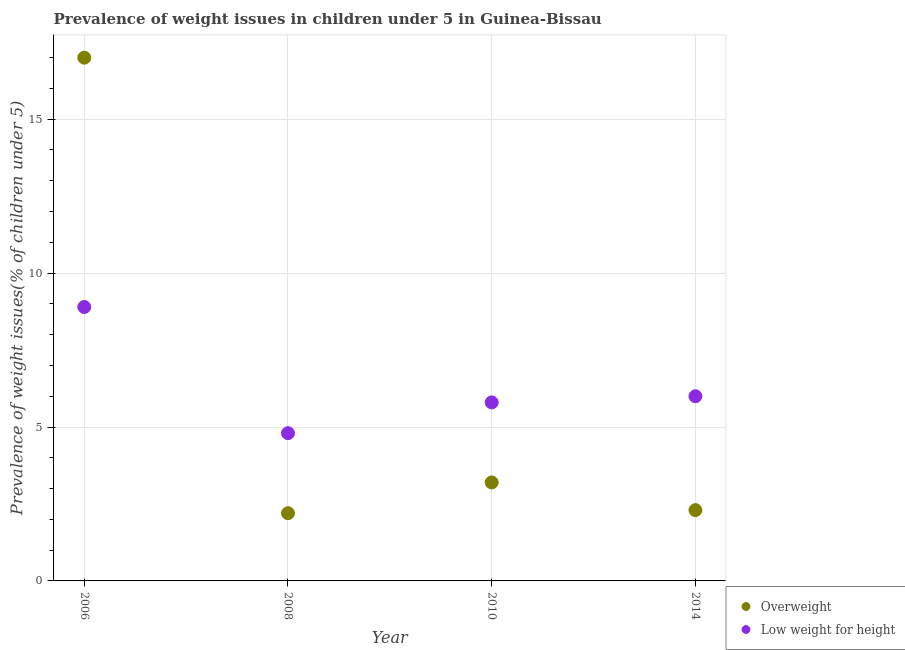How many different coloured dotlines are there?
Ensure brevity in your answer.  2. Is the number of dotlines equal to the number of legend labels?
Provide a short and direct response. Yes. What is the percentage of overweight children in 2008?
Provide a short and direct response. 2.2. Across all years, what is the minimum percentage of overweight children?
Keep it short and to the point. 2.2. What is the total percentage of overweight children in the graph?
Make the answer very short. 24.7. What is the difference between the percentage of underweight children in 2008 and that in 2014?
Keep it short and to the point. -1.2. What is the difference between the percentage of underweight children in 2010 and the percentage of overweight children in 2008?
Keep it short and to the point. 3.6. What is the average percentage of underweight children per year?
Your response must be concise. 6.37. In the year 2008, what is the difference between the percentage of overweight children and percentage of underweight children?
Keep it short and to the point. -2.6. What is the ratio of the percentage of underweight children in 2006 to that in 2010?
Offer a terse response. 1.53. Is the percentage of overweight children in 2008 less than that in 2014?
Your response must be concise. Yes. Is the difference between the percentage of underweight children in 2006 and 2010 greater than the difference between the percentage of overweight children in 2006 and 2010?
Offer a very short reply. No. What is the difference between the highest and the second highest percentage of overweight children?
Provide a short and direct response. 13.8. What is the difference between the highest and the lowest percentage of overweight children?
Provide a short and direct response. 14.8. Is the sum of the percentage of underweight children in 2006 and 2008 greater than the maximum percentage of overweight children across all years?
Make the answer very short. No. Is the percentage of underweight children strictly greater than the percentage of overweight children over the years?
Your response must be concise. No. How many years are there in the graph?
Your response must be concise. 4. What is the difference between two consecutive major ticks on the Y-axis?
Offer a very short reply. 5. Does the graph contain any zero values?
Your answer should be very brief. No. Where does the legend appear in the graph?
Provide a short and direct response. Bottom right. What is the title of the graph?
Your answer should be very brief. Prevalence of weight issues in children under 5 in Guinea-Bissau. Does "% of GNI" appear as one of the legend labels in the graph?
Your answer should be very brief. No. What is the label or title of the X-axis?
Your answer should be compact. Year. What is the label or title of the Y-axis?
Ensure brevity in your answer.  Prevalence of weight issues(% of children under 5). What is the Prevalence of weight issues(% of children under 5) in Low weight for height in 2006?
Provide a short and direct response. 8.9. What is the Prevalence of weight issues(% of children under 5) in Overweight in 2008?
Provide a succinct answer. 2.2. What is the Prevalence of weight issues(% of children under 5) of Low weight for height in 2008?
Provide a short and direct response. 4.8. What is the Prevalence of weight issues(% of children under 5) in Overweight in 2010?
Provide a short and direct response. 3.2. What is the Prevalence of weight issues(% of children under 5) in Low weight for height in 2010?
Provide a succinct answer. 5.8. What is the Prevalence of weight issues(% of children under 5) in Overweight in 2014?
Ensure brevity in your answer.  2.3. Across all years, what is the maximum Prevalence of weight issues(% of children under 5) in Overweight?
Provide a short and direct response. 17. Across all years, what is the maximum Prevalence of weight issues(% of children under 5) in Low weight for height?
Offer a terse response. 8.9. Across all years, what is the minimum Prevalence of weight issues(% of children under 5) of Overweight?
Provide a succinct answer. 2.2. Across all years, what is the minimum Prevalence of weight issues(% of children under 5) of Low weight for height?
Offer a very short reply. 4.8. What is the total Prevalence of weight issues(% of children under 5) of Overweight in the graph?
Give a very brief answer. 24.7. What is the total Prevalence of weight issues(% of children under 5) of Low weight for height in the graph?
Make the answer very short. 25.5. What is the difference between the Prevalence of weight issues(% of children under 5) of Overweight in 2006 and that in 2008?
Your response must be concise. 14.8. What is the difference between the Prevalence of weight issues(% of children under 5) of Low weight for height in 2006 and that in 2008?
Offer a very short reply. 4.1. What is the difference between the Prevalence of weight issues(% of children under 5) in Overweight in 2006 and that in 2014?
Your response must be concise. 14.7. What is the difference between the Prevalence of weight issues(% of children under 5) in Overweight in 2008 and that in 2010?
Provide a short and direct response. -1. What is the difference between the Prevalence of weight issues(% of children under 5) of Low weight for height in 2008 and that in 2010?
Provide a short and direct response. -1. What is the difference between the Prevalence of weight issues(% of children under 5) of Overweight in 2008 and that in 2014?
Give a very brief answer. -0.1. What is the difference between the Prevalence of weight issues(% of children under 5) of Low weight for height in 2008 and that in 2014?
Offer a very short reply. -1.2. What is the difference between the Prevalence of weight issues(% of children under 5) of Overweight in 2008 and the Prevalence of weight issues(% of children under 5) of Low weight for height in 2014?
Provide a short and direct response. -3.8. What is the difference between the Prevalence of weight issues(% of children under 5) of Overweight in 2010 and the Prevalence of weight issues(% of children under 5) of Low weight for height in 2014?
Provide a succinct answer. -2.8. What is the average Prevalence of weight issues(% of children under 5) in Overweight per year?
Give a very brief answer. 6.17. What is the average Prevalence of weight issues(% of children under 5) in Low weight for height per year?
Keep it short and to the point. 6.38. In the year 2006, what is the difference between the Prevalence of weight issues(% of children under 5) in Overweight and Prevalence of weight issues(% of children under 5) in Low weight for height?
Your answer should be very brief. 8.1. In the year 2014, what is the difference between the Prevalence of weight issues(% of children under 5) of Overweight and Prevalence of weight issues(% of children under 5) of Low weight for height?
Offer a terse response. -3.7. What is the ratio of the Prevalence of weight issues(% of children under 5) of Overweight in 2006 to that in 2008?
Your answer should be compact. 7.73. What is the ratio of the Prevalence of weight issues(% of children under 5) in Low weight for height in 2006 to that in 2008?
Offer a very short reply. 1.85. What is the ratio of the Prevalence of weight issues(% of children under 5) of Overweight in 2006 to that in 2010?
Provide a succinct answer. 5.31. What is the ratio of the Prevalence of weight issues(% of children under 5) in Low weight for height in 2006 to that in 2010?
Your response must be concise. 1.53. What is the ratio of the Prevalence of weight issues(% of children under 5) of Overweight in 2006 to that in 2014?
Offer a terse response. 7.39. What is the ratio of the Prevalence of weight issues(% of children under 5) in Low weight for height in 2006 to that in 2014?
Give a very brief answer. 1.48. What is the ratio of the Prevalence of weight issues(% of children under 5) in Overweight in 2008 to that in 2010?
Your answer should be compact. 0.69. What is the ratio of the Prevalence of weight issues(% of children under 5) of Low weight for height in 2008 to that in 2010?
Offer a terse response. 0.83. What is the ratio of the Prevalence of weight issues(% of children under 5) of Overweight in 2008 to that in 2014?
Offer a terse response. 0.96. What is the ratio of the Prevalence of weight issues(% of children under 5) in Overweight in 2010 to that in 2014?
Your response must be concise. 1.39. What is the ratio of the Prevalence of weight issues(% of children under 5) of Low weight for height in 2010 to that in 2014?
Your response must be concise. 0.97. What is the difference between the highest and the second highest Prevalence of weight issues(% of children under 5) of Overweight?
Provide a succinct answer. 13.8. What is the difference between the highest and the lowest Prevalence of weight issues(% of children under 5) of Overweight?
Keep it short and to the point. 14.8. 